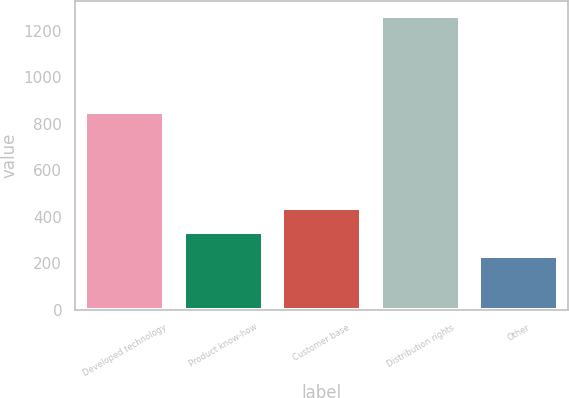Convert chart to OTSL. <chart><loc_0><loc_0><loc_500><loc_500><bar_chart><fcel>Developed technology<fcel>Product know-how<fcel>Customer base<fcel>Distribution rights<fcel>Other<nl><fcel>851<fcel>333.5<fcel>437<fcel>1265<fcel>230<nl></chart> 